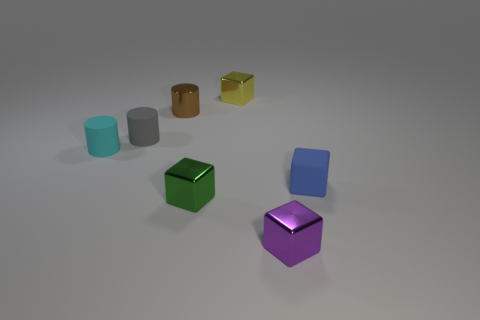What is the color of the tiny shiny object on the left side of the small cube that is left of the metal object that is behind the small brown cylinder?
Your answer should be compact. Brown. How many things are both to the right of the brown metallic cylinder and in front of the tiny gray matte cylinder?
Your answer should be very brief. 3. Is there any other thing that is made of the same material as the green object?
Offer a terse response. Yes. The yellow shiny object that is the same shape as the green shiny object is what size?
Ensure brevity in your answer.  Small. There is a tiny brown metal object; are there any small brown metallic things to the right of it?
Provide a succinct answer. No. Is the number of yellow things in front of the small purple shiny block the same as the number of blue objects?
Your answer should be very brief. No. There is a small block that is behind the matte thing that is on the right side of the small yellow metallic cube; are there any gray rubber cylinders behind it?
Your response must be concise. No. What is the small gray object made of?
Make the answer very short. Rubber. What number of other objects are there of the same shape as the small yellow object?
Offer a very short reply. 3. Do the brown metallic object and the small cyan matte thing have the same shape?
Give a very brief answer. Yes. 